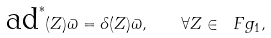Convert formula to latex. <formula><loc_0><loc_0><loc_500><loc_500>\text {ad} ^ { \ast } ( Z ) \varpi = \delta ( Z ) \varpi , \quad \forall Z \in \ F g _ { 1 } ,</formula> 